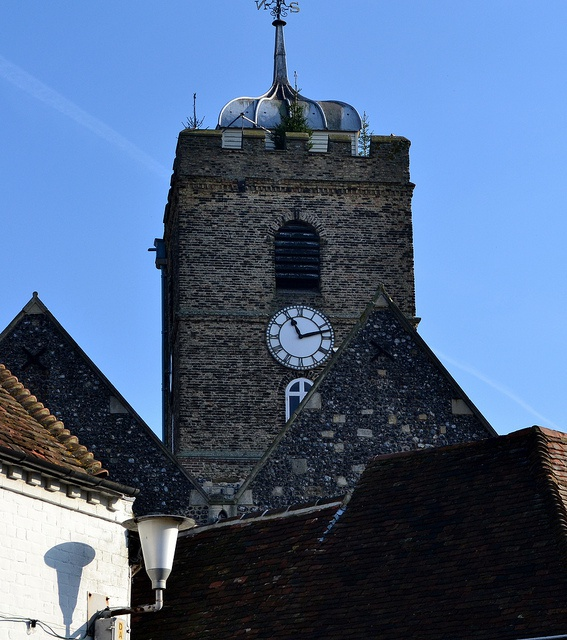Describe the objects in this image and their specific colors. I can see a clock in lightblue, darkgray, black, navy, and gray tones in this image. 